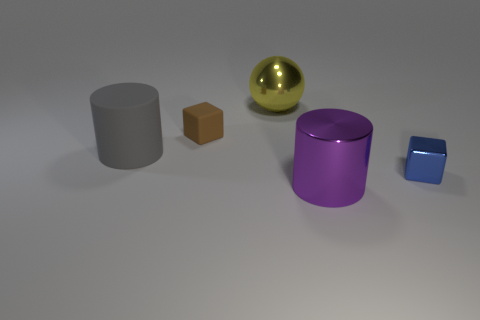Add 3 tiny objects. How many objects exist? 8 Subtract all balls. How many objects are left? 4 Add 2 large gray things. How many large gray things are left? 3 Add 1 gray cylinders. How many gray cylinders exist? 2 Subtract 0 yellow blocks. How many objects are left? 5 Subtract all blocks. Subtract all large purple shiny objects. How many objects are left? 2 